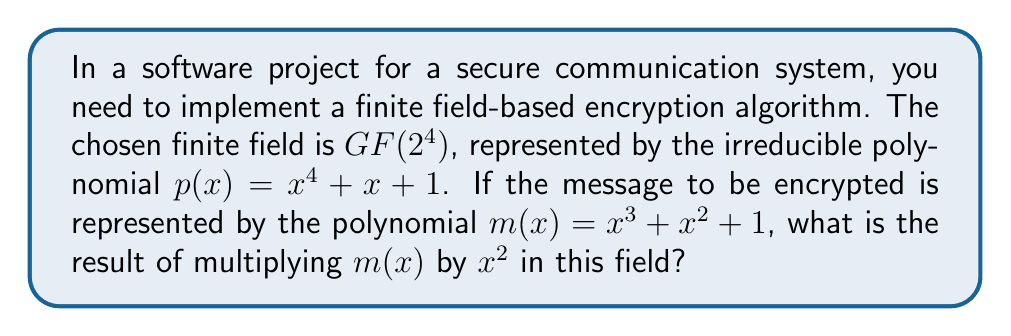Help me with this question. To solve this problem, we need to follow these steps:

1) First, multiply $m(x)$ by $x^2$:
   $$(x^3 + x^2 + 1) \cdot x^2 = x^5 + x^4 + x^2$$

2) Now, we need to reduce this result modulo the irreducible polynomial $p(x) = x^4 + x + 1$. We do this by replacing any $x^4$ terms with $x + 1$, and then simplifying:

   $x^5 + x^4 + x^2$
   $= x \cdot x^4 + x^4 + x^2$
   $= x(x + 1) + (x + 1) + x^2$
   $= x^2 + x + x + 1 + x^2$
   $= 2x^2 + 2x + 1$

3) In $GF(2^4)$, addition is performed modulo 2, so $2x^2$ becomes $0$ and $2x$ becomes $0$:

   $2x^2 + 2x + 1 \equiv 1 \pmod{2}$

Therefore, the result of multiplying $m(x)$ by $x^2$ in $GF(2^4)$ is simply 1.

This process demonstrates how arithmetic operations in finite fields are performed, which is crucial for implementing cryptographic algorithms. The use of irreducible polynomials to define the field ensures that every non-zero element has a multiplicative inverse, a property that's essential for many cryptographic operations.
Answer: 1 